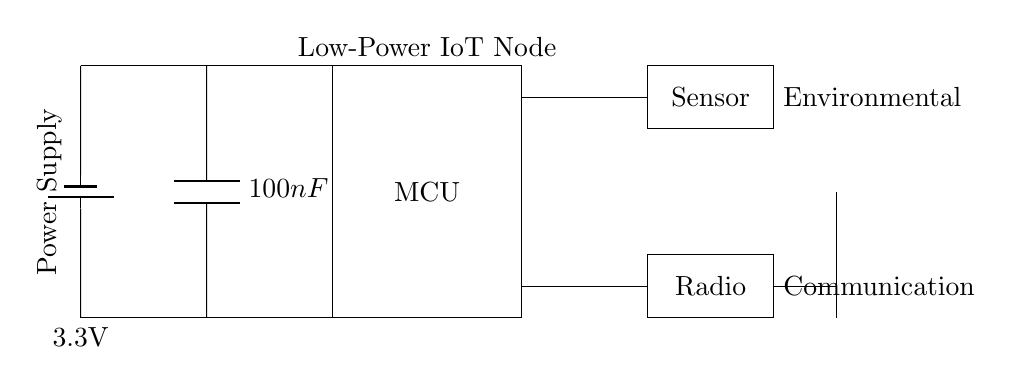What is the power supply voltage? The voltage is shown as 3.3V, which is the potential difference provided by the battery in the diagram.
Answer: 3.3V What component is responsible for communication? The radio component is specifically designed for communication purposes, as indicated in the circuit diagram.
Answer: Radio What type of capacitor is used in the circuit? The capacitor is labeled as 100nF, which indicates its capacitance value, typically used for decoupling to stabilize voltage levels.
Answer: 100nF How many main components are in the circuit? The circuit has four main components: the microcontroller, power supply, sensor, and radio.
Answer: Four What is the purpose of the decoupling capacitor? The capacitor serves to filter voltage fluctuations and maintain a stable supply voltage for the microcontroller, enhancing performance and reliability.
Answer: Stabilization What is connected to the antenna? The antenna is connected to the radio, which serves as the communication link for data transmission and reception in the IoT device.
Answer: Radio Why is a low-power microcontroller used? A low-power microcontroller is crucial for IoT sensor nodes to conserve battery life and ensure long-term operation in energy-sensitive applications.
Answer: Energy efficiency 